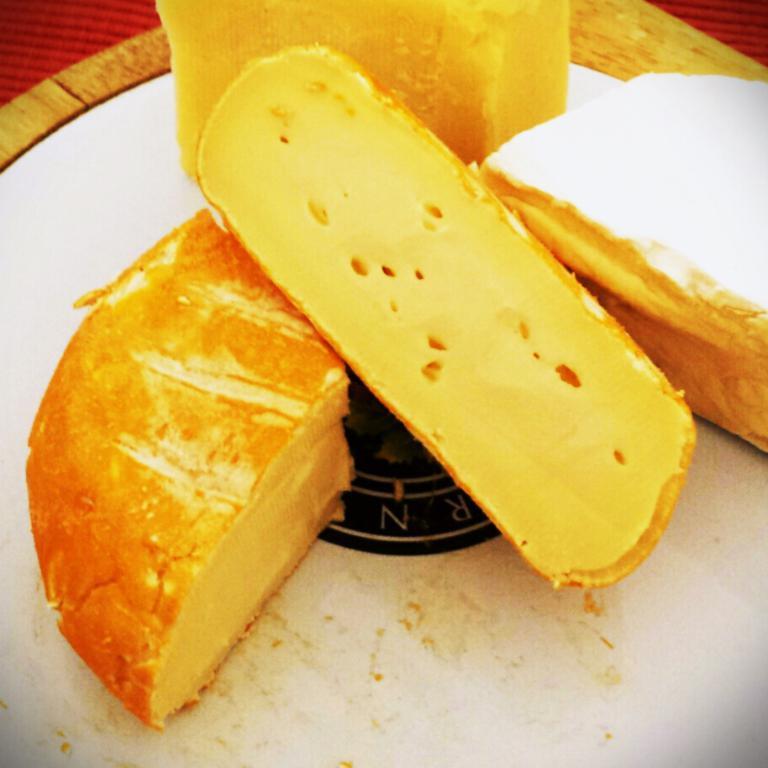Please provide a concise description of this image. In the picture I can see some food item is kept on the white color surface. Here I can see some object is in red color. 